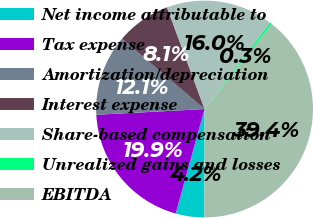<chart> <loc_0><loc_0><loc_500><loc_500><pie_chart><fcel>Net income attributable to<fcel>Tax expense<fcel>Amortization/depreciation<fcel>Interest expense<fcel>Share-based compensation<fcel>Unrealized gains and losses<fcel>EBITDA<nl><fcel>4.25%<fcel>19.86%<fcel>12.06%<fcel>8.15%<fcel>15.96%<fcel>0.35%<fcel>39.38%<nl></chart> 